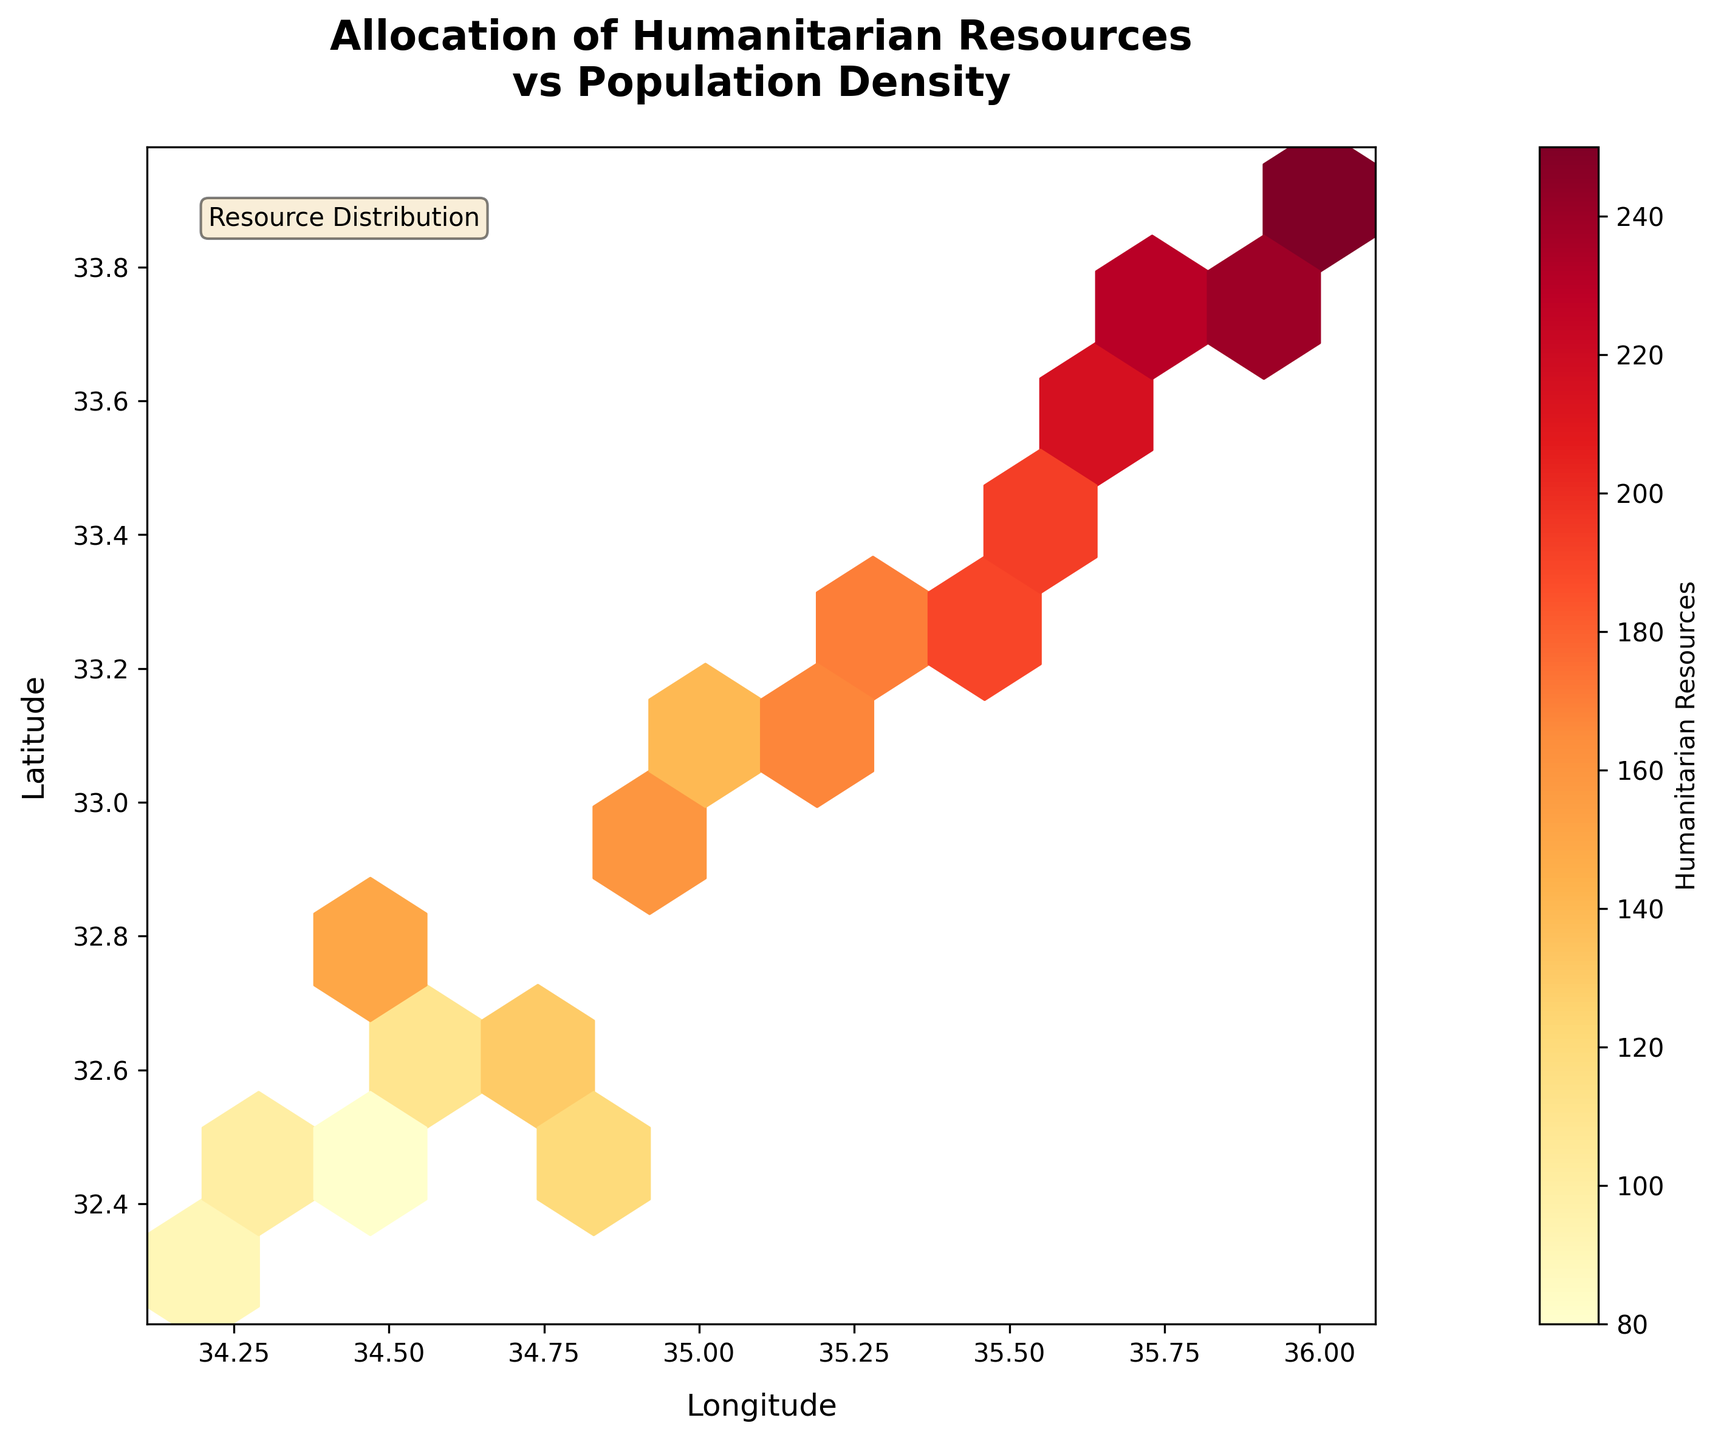How many data points are shown on the hexbin plot? You can count the number of hexagons in the plot. Each hexagon represents an aggregated count of points.
Answer: Count the hexagons What is the title of the figure? The title is displayed at the top of the figure in the largest font size.
Answer: Allocation of Humanitarian Resources vs Population Density What do the hexagon colors represent? The color bar on the right side of the plot indicates that the colors represent the amount of humanitarian resources.
Answer: Humanitarian resources Which axis represents longitude? The x-axis label indicates 'Longitude', so it represents the longitude in the plot.
Answer: X-axis Which axis represents latitude? The y-axis label indicates 'Latitude', so it represents the latitude in the plot.
Answer: Y-axis Which region seems to have the highest concentration of resources? Darker shades in the hexbin plot towards the top right indicate higher concentrations. The color bar also helps in identifying this area.
Answer: Top-right How does resource allocation change as we move from lower left to upper right of the plot? As we move from lower left to upper right, the hexagon colors become darker, indicating an increase in the allocation of humanitarian resources.
Answer: Increases What area on the plot has the least amount of resources allocated? Lighter hexagons towards the bottom left indicate fewer resources allocated.
Answer: Bottom-left If you were to sum all the values represented by hexagons, would the concentration be higher in the north-east or south-west? Summing the values depends on the visible darker shades, indicating higher resource allocation. The north-east region shows darker colors, implying more resources.
Answer: North-east Comparing the central part to the fringes of the plot, which has a higher average resource allocation? The color density indicates resource allocation. The central part has medium shades, whereas the fringes, especially bottom left, shows lighter shades. Thus, the central part has a higher average allocation.
Answer: Central part 